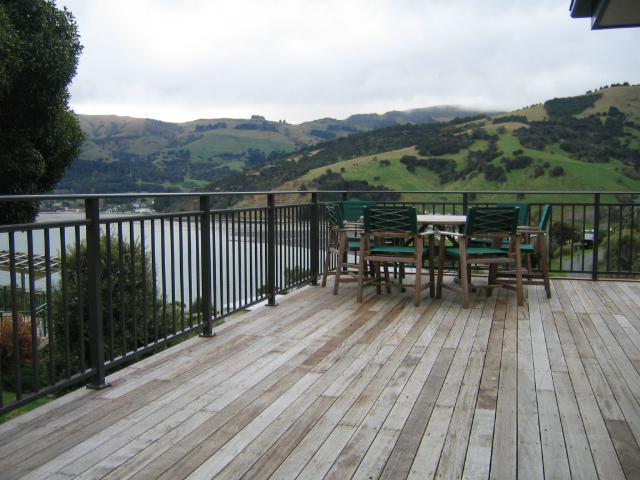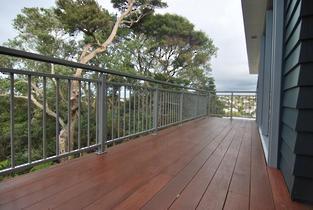The first image is the image on the left, the second image is the image on the right. For the images displayed, is the sentence "The right image shows a straight metal rail with vertical bars at the edge of a stained brown plank deck that overlooks dense foliage and trees." factually correct? Answer yes or no. Yes. The first image is the image on the left, the second image is the image on the right. Assess this claim about the two images: "In at least one image there are columns attached to the building and at least a strip of cement.". Correct or not? Answer yes or no. No. 